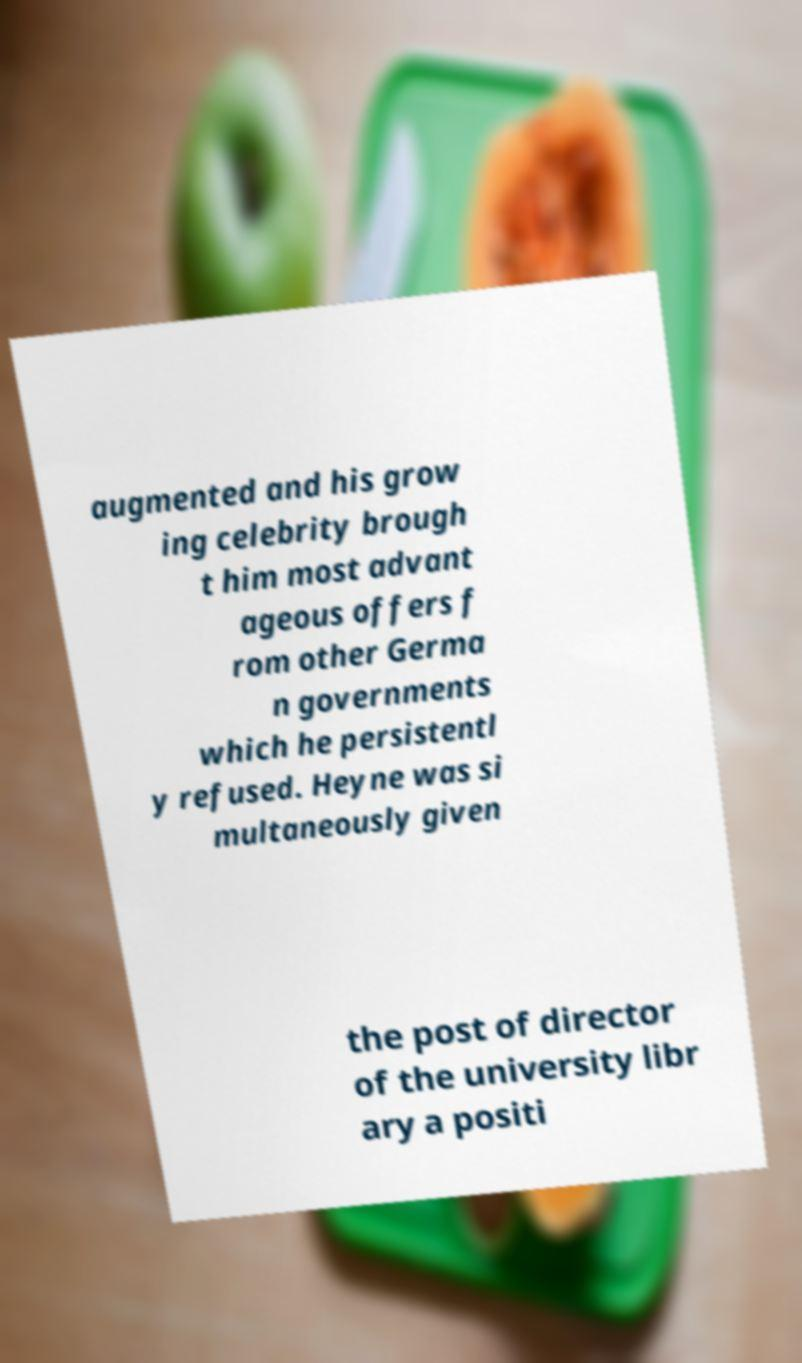Please read and relay the text visible in this image. What does it say? augmented and his grow ing celebrity brough t him most advant ageous offers f rom other Germa n governments which he persistentl y refused. Heyne was si multaneously given the post of director of the university libr ary a positi 